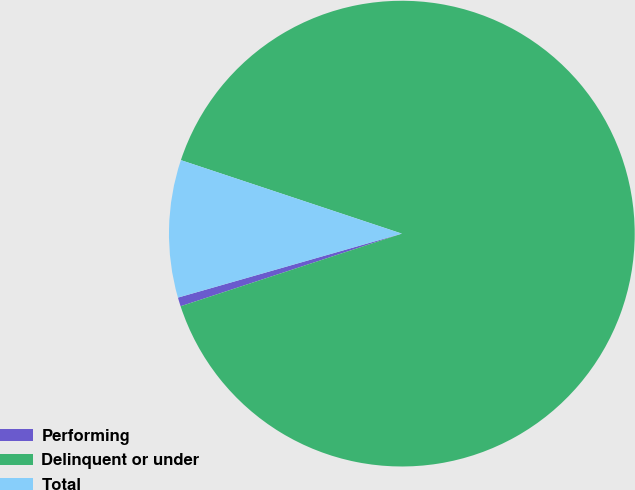Convert chart. <chart><loc_0><loc_0><loc_500><loc_500><pie_chart><fcel>Performing<fcel>Delinquent or under<fcel>Total<nl><fcel>0.62%<fcel>89.85%<fcel>9.54%<nl></chart> 